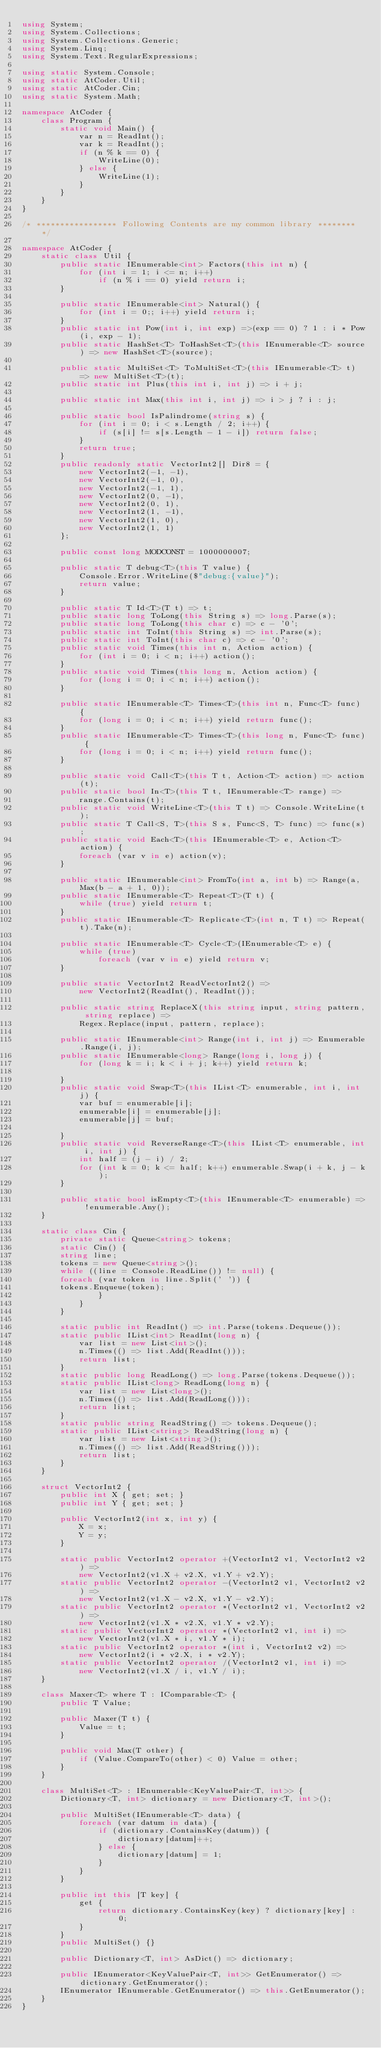Convert code to text. <code><loc_0><loc_0><loc_500><loc_500><_C#_>using System;
using System.Collections;
using System.Collections.Generic;
using System.Linq;
using System.Text.RegularExpressions;

using static System.Console;
using static AtCoder.Util;
using static AtCoder.Cin;
using static System.Math;

namespace AtCoder {
    class Program {
        static void Main() {
            var n = ReadInt();
            var k = ReadInt();
            if (n % k == 0) {
                WriteLine(0);
            } else {
                WriteLine(1);
            }
        }
    }
}

/* ***************** Following Contents are my common library ******** */

namespace AtCoder {
    static class Util {
        public static IEnumerable<int> Factors(this int n) {
            for (int i = 1; i <= n; i++)
                if (n % i == 0) yield return i;
        }

        public static IEnumerable<int> Natural() {
            for (int i = 0;; i++) yield return i;
        }
        public static int Pow(int i, int exp) =>(exp == 0) ? 1 : i * Pow(i, exp - 1);
        public static HashSet<T> ToHashSet<T>(this IEnumerable<T> source) => new HashSet<T>(source);

        public static MultiSet<T> ToMultiSet<T>(this IEnumerable<T> t) => new MultiSet<T>(t);
        public static int Plus(this int i, int j) => i + j;

        public static int Max(this int i, int j) => i > j ? i : j;

        public static bool IsPalindrome(string s) {
            for (int i = 0; i < s.Length / 2; i++) {
                if (s[i] != s[s.Length - 1 - i]) return false;
            }
            return true;
        }
        public readonly static VectorInt2[] Dir8 = {
            new VectorInt2(-1, -1),
            new VectorInt2(-1, 0),
            new VectorInt2(-1, 1),
            new VectorInt2(0, -1),
            new VectorInt2(0, 1),
            new VectorInt2(1, -1),
            new VectorInt2(1, 0),
            new VectorInt2(1, 1)
        };

        public const long MODCONST = 1000000007;

        public static T debug<T>(this T value) {
            Console.Error.WriteLine($"debug:{value}");
            return value;
        }

        public static T Id<T>(T t) => t;
        public static long ToLong(this String s) => long.Parse(s);
        public static long ToLong(this char c) => c - '0';
        public static int ToInt(this String s) => int.Parse(s);
        public static int ToInt(this char c) => c - '0';
        public static void Times(this int n, Action action) {
            for (int i = 0; i < n; i++) action();
        }
        public static void Times(this long n, Action action) {
            for (long i = 0; i < n; i++) action();
        }

        public static IEnumerable<T> Times<T>(this int n, Func<T> func) {
            for (long i = 0; i < n; i++) yield return func();
        }
        public static IEnumerable<T> Times<T>(this long n, Func<T> func) {
            for (long i = 0; i < n; i++) yield return func();
        }

        public static void Call<T>(this T t, Action<T> action) => action(t);
        public static bool In<T>(this T t, IEnumerable<T> range) =>
            range.Contains(t);
        public static void WriteLine<T>(this T t) => Console.WriteLine(t);
        public static T Call<S, T>(this S s, Func<S, T> func) => func(s);
        public static void Each<T>(this IEnumerable<T> e, Action<T> action) {
            foreach (var v in e) action(v);
        }

        public static IEnumerable<int> FromTo(int a, int b) => Range(a, Max(b - a + 1, 0));
        public static IEnumerable<T> Repeat<T>(T t) {
            while (true) yield return t;
        }
        public static IEnumerable<T> Replicate<T>(int n, T t) => Repeat(t).Take(n);

        public static IEnumerable<T> Cycle<T>(IEnumerable<T> e) {
            while (true)
                foreach (var v in e) yield return v;
        }

        public static VectorInt2 ReadVectorInt2() =>
            new VectorInt2(ReadInt(), ReadInt());

        public static string ReplaceX(this string input, string pattern, string replace) =>
            Regex.Replace(input, pattern, replace);

        public static IEnumerable<int> Range(int i, int j) => Enumerable.Range(i, j);
        public static IEnumerable<long> Range(long i, long j) {
            for (long k = i; k < i + j; k++) yield return k;

        }
        public static void Swap<T>(this IList<T> enumerable, int i, int j) {
            var buf = enumerable[i];
            enumerable[i] = enumerable[j];
            enumerable[j] = buf;

        }
        public static void ReverseRange<T>(this IList<T> enumerable, int i, int j) {
            int half = (j - i) / 2;
            for (int k = 0; k <= half; k++) enumerable.Swap(i + k, j - k);
        }

        public static bool isEmpty<T>(this IEnumerable<T> enumerable) => !enumerable.Any();
    }

    static class Cin {
        private static Queue<string> tokens;
        static Cin() {
        string line;
        tokens = new Queue<string>();
        while ((line = Console.ReadLine()) != null) {
        foreach (var token in line.Split(' ')) {
        tokens.Enqueue(token);
                }
            }
        }

        static public int ReadInt() => int.Parse(tokens.Dequeue());
        static public IList<int> ReadInt(long n) {
            var list = new List<int>();
            n.Times(() => list.Add(ReadInt()));
            return list;
        }
        static public long ReadLong() => long.Parse(tokens.Dequeue());
        static public IList<long> ReadLong(long n) {
            var list = new List<long>();
            n.Times(() => list.Add(ReadLong()));
            return list;
        }
        static public string ReadString() => tokens.Dequeue();
        static public IList<string> ReadString(long n) {
            var list = new List<string>();
            n.Times(() => list.Add(ReadString()));
            return list;
        }
    }

    struct VectorInt2 {
        public int X { get; set; }
        public int Y { get; set; }

        public VectorInt2(int x, int y) {
            X = x;
            Y = y;
        }

        static public VectorInt2 operator +(VectorInt2 v1, VectorInt2 v2) =>
            new VectorInt2(v1.X + v2.X, v1.Y + v2.Y);
        static public VectorInt2 operator -(VectorInt2 v1, VectorInt2 v2) =>
            new VectorInt2(v1.X - v2.X, v1.Y - v2.Y);
        static public VectorInt2 operator *(VectorInt2 v1, VectorInt2 v2) =>
            new VectorInt2(v1.X * v2.X, v1.Y * v2.Y);
        static public VectorInt2 operator *(VectorInt2 v1, int i) =>
            new VectorInt2(v1.X * i, v1.Y * i);
        static public VectorInt2 operator *(int i, VectorInt2 v2) =>
            new VectorInt2(i * v2.X, i * v2.Y);
        static public VectorInt2 operator /(VectorInt2 v1, int i) =>
            new VectorInt2(v1.X / i, v1.Y / i);
    }

    class Maxer<T> where T : IComparable<T> {
        public T Value;

        public Maxer(T t) {
            Value = t;
        }

        public void Max(T other) {
            if (Value.CompareTo(other) < 0) Value = other;
        }
    }

    class MultiSet<T> : IEnumerable<KeyValuePair<T, int>> {
        Dictionary<T, int> dictionary = new Dictionary<T, int>();

        public MultiSet(IEnumerable<T> data) {
            foreach (var datum in data) {
                if (dictionary.ContainsKey(datum)) {
                    dictionary[datum]++;
                } else {
                    dictionary[datum] = 1;
                }
            }
        }

        public int this [T key] {
            get {
                return dictionary.ContainsKey(key) ? dictionary[key] : 0;
            }
        }
        public MultiSet() {}

        public Dictionary<T, int> AsDict() => dictionary;

        public IEnumerator<KeyValuePair<T, int>> GetEnumerator() => dictionary.GetEnumerator();
        IEnumerator IEnumerable.GetEnumerator() => this.GetEnumerator();
    }
}
</code> 